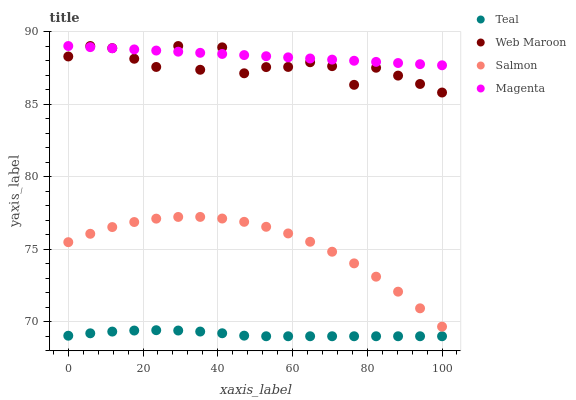Does Teal have the minimum area under the curve?
Answer yes or no. Yes. Does Magenta have the maximum area under the curve?
Answer yes or no. Yes. Does Web Maroon have the minimum area under the curve?
Answer yes or no. No. Does Web Maroon have the maximum area under the curve?
Answer yes or no. No. Is Magenta the smoothest?
Answer yes or no. Yes. Is Web Maroon the roughest?
Answer yes or no. Yes. Is Web Maroon the smoothest?
Answer yes or no. No. Is Magenta the roughest?
Answer yes or no. No. Does Teal have the lowest value?
Answer yes or no. Yes. Does Web Maroon have the lowest value?
Answer yes or no. No. Does Web Maroon have the highest value?
Answer yes or no. Yes. Does Teal have the highest value?
Answer yes or no. No. Is Teal less than Magenta?
Answer yes or no. Yes. Is Magenta greater than Teal?
Answer yes or no. Yes. Does Web Maroon intersect Magenta?
Answer yes or no. Yes. Is Web Maroon less than Magenta?
Answer yes or no. No. Is Web Maroon greater than Magenta?
Answer yes or no. No. Does Teal intersect Magenta?
Answer yes or no. No. 